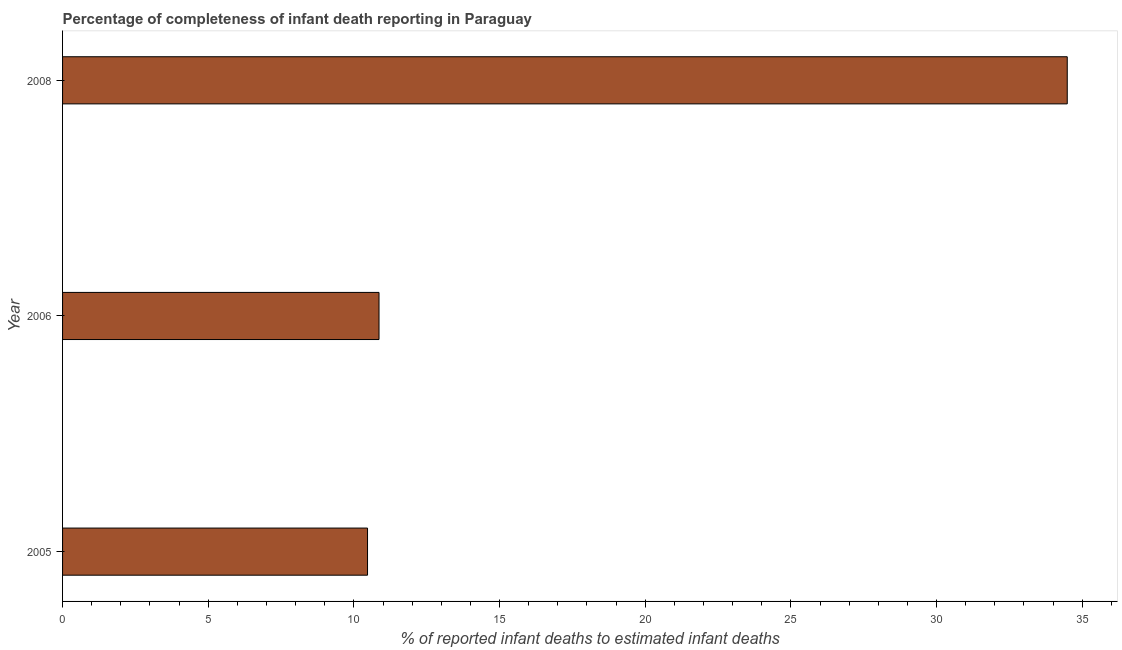Does the graph contain grids?
Offer a very short reply. No. What is the title of the graph?
Offer a terse response. Percentage of completeness of infant death reporting in Paraguay. What is the label or title of the X-axis?
Offer a very short reply. % of reported infant deaths to estimated infant deaths. What is the label or title of the Y-axis?
Provide a succinct answer. Year. What is the completeness of infant death reporting in 2005?
Ensure brevity in your answer.  10.47. Across all years, what is the maximum completeness of infant death reporting?
Give a very brief answer. 34.49. Across all years, what is the minimum completeness of infant death reporting?
Provide a short and direct response. 10.47. What is the sum of the completeness of infant death reporting?
Provide a succinct answer. 55.82. What is the difference between the completeness of infant death reporting in 2005 and 2006?
Your answer should be very brief. -0.4. What is the average completeness of infant death reporting per year?
Provide a short and direct response. 18.61. What is the median completeness of infant death reporting?
Provide a short and direct response. 10.86. What is the ratio of the completeness of infant death reporting in 2005 to that in 2008?
Offer a terse response. 0.3. Is the difference between the completeness of infant death reporting in 2005 and 2006 greater than the difference between any two years?
Provide a short and direct response. No. What is the difference between the highest and the second highest completeness of infant death reporting?
Make the answer very short. 23.62. Is the sum of the completeness of infant death reporting in 2005 and 2008 greater than the maximum completeness of infant death reporting across all years?
Provide a short and direct response. Yes. What is the difference between the highest and the lowest completeness of infant death reporting?
Ensure brevity in your answer.  24.02. How many bars are there?
Offer a terse response. 3. Are the values on the major ticks of X-axis written in scientific E-notation?
Make the answer very short. No. What is the % of reported infant deaths to estimated infant deaths of 2005?
Give a very brief answer. 10.47. What is the % of reported infant deaths to estimated infant deaths of 2006?
Offer a very short reply. 10.86. What is the % of reported infant deaths to estimated infant deaths in 2008?
Offer a very short reply. 34.49. What is the difference between the % of reported infant deaths to estimated infant deaths in 2005 and 2006?
Ensure brevity in your answer.  -0.39. What is the difference between the % of reported infant deaths to estimated infant deaths in 2005 and 2008?
Provide a short and direct response. -24.02. What is the difference between the % of reported infant deaths to estimated infant deaths in 2006 and 2008?
Give a very brief answer. -23.62. What is the ratio of the % of reported infant deaths to estimated infant deaths in 2005 to that in 2006?
Offer a very short reply. 0.96. What is the ratio of the % of reported infant deaths to estimated infant deaths in 2005 to that in 2008?
Offer a very short reply. 0.3. What is the ratio of the % of reported infant deaths to estimated infant deaths in 2006 to that in 2008?
Offer a very short reply. 0.32. 